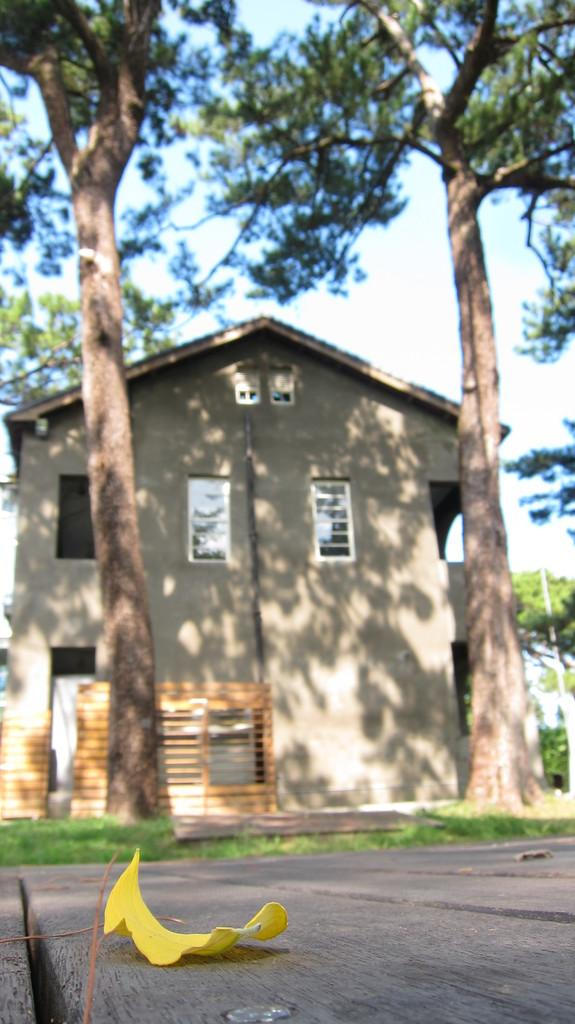What type of structure is in the picture? There is a house in the picture. What feature can be seen on the house? The house has glass windows. What can be seen on the side of the road? There are two trees on the side of the road. Where is a leaf located in the picture? A leaf is visible on the road in the bottom left side of the picture. What direction is the current flowing in the picture? There is no body of water or indication of a current in the picture. Is there a rake visible in the picture? No, there is no rake present in the image. 